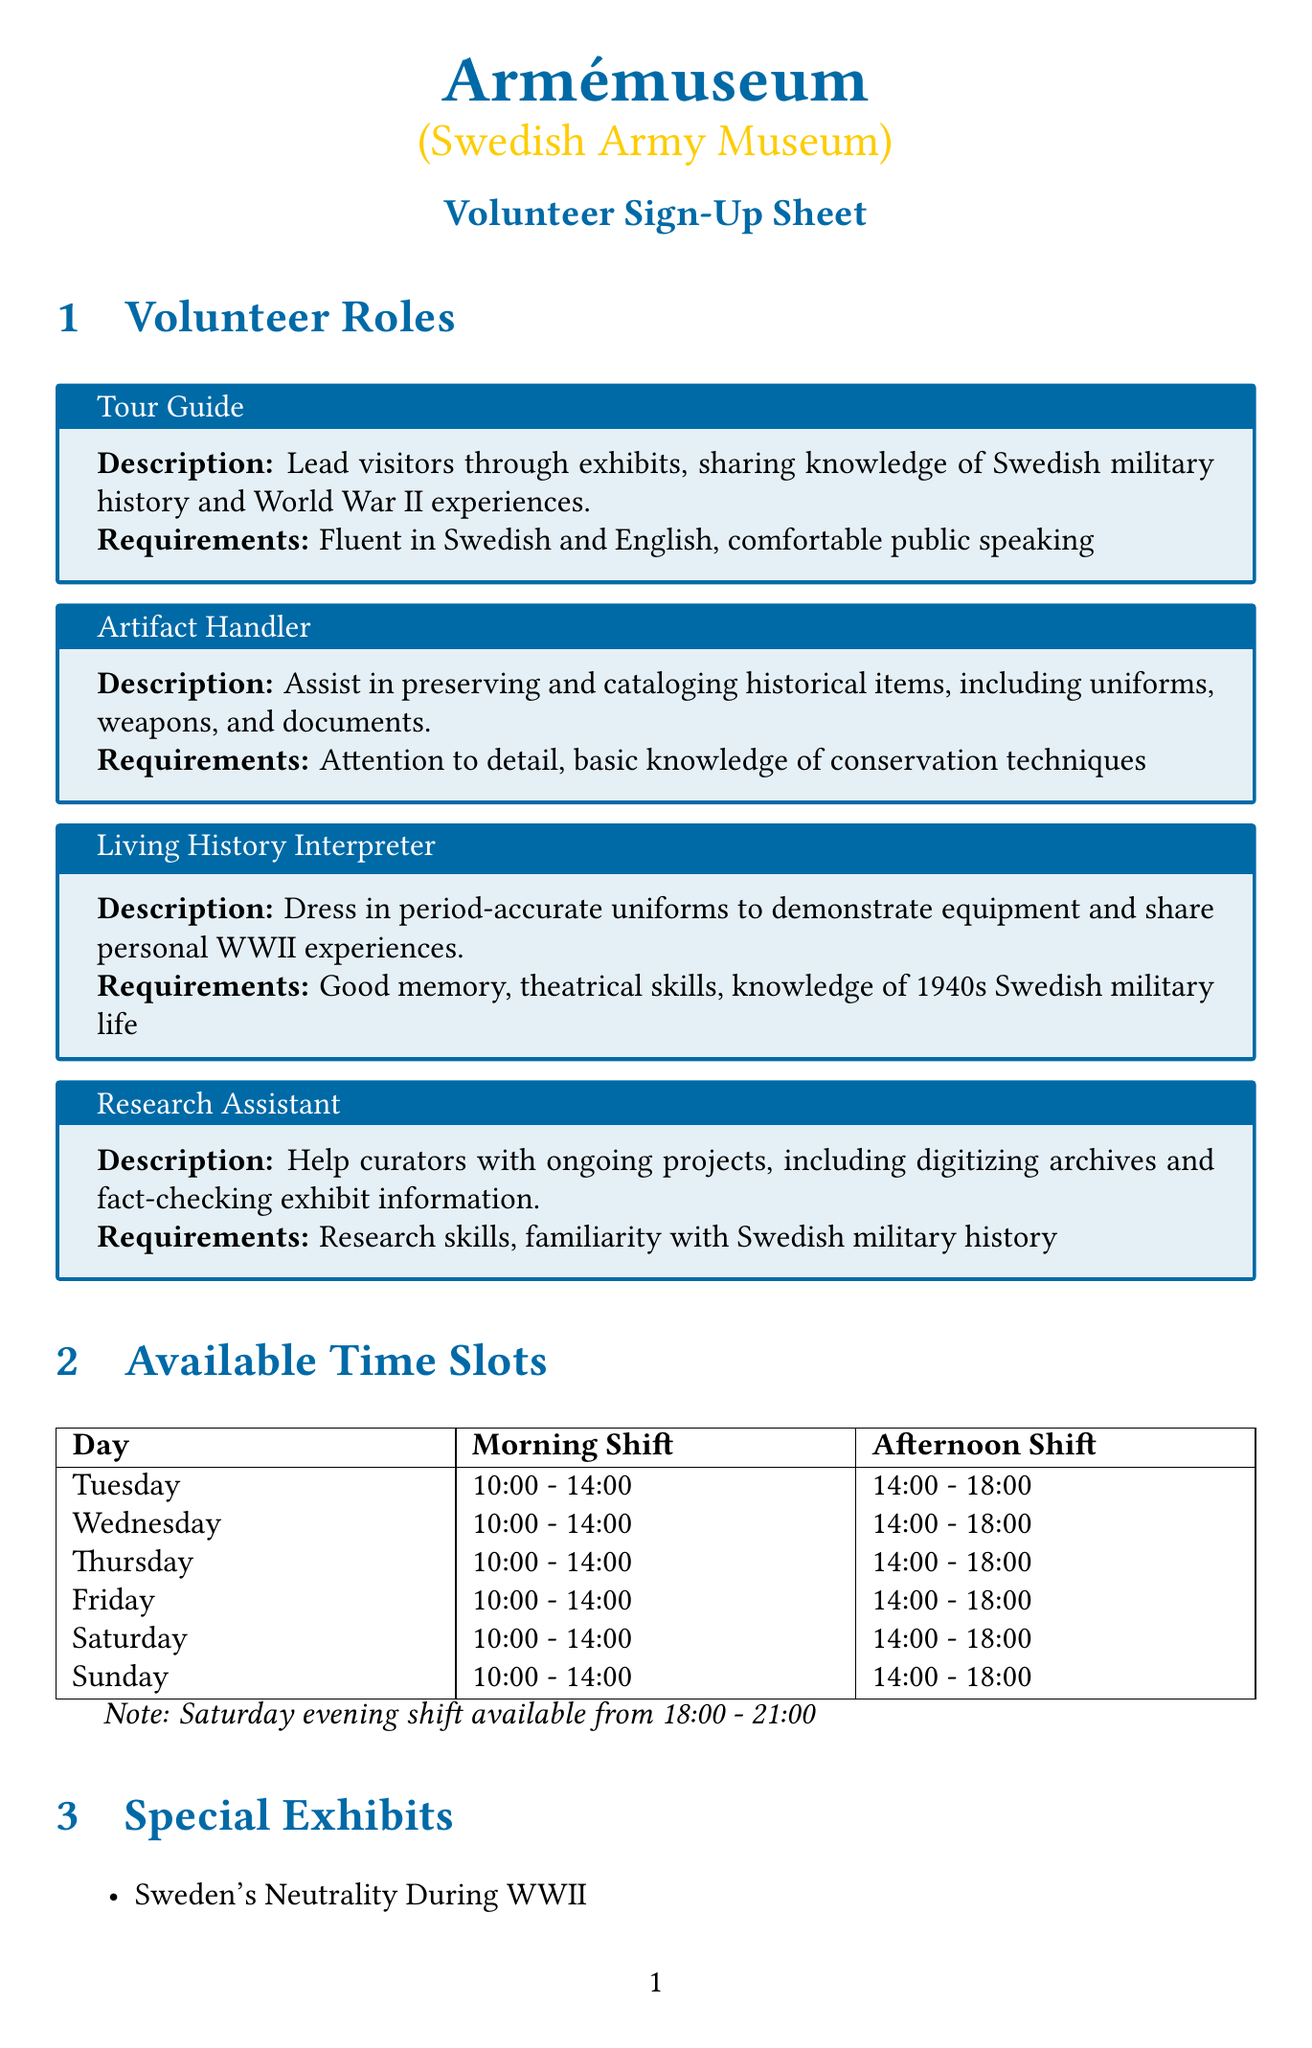What is the name of the museum? The name of the museum is stated in the document and is "Armémuseum (Swedish Army Museum)".
Answer: Armémuseum (Swedish Army Museum) Who is the coordinator for volunteers? The document provides the name of the volunteer coordinator, which is Major (Ret.) Sven Lindberg.
Answer: Major (Ret.) Sven Lindberg What are the requirements for the Tour Guide role? The requirements listed for the Tour Guide role are specific skills, including language proficiency and public speaking comfort.
Answer: Fluent in Swedish and English, comfortable public speaking How many special exhibits are mentioned? The document lists the number of special exhibits related to Swedish military history, which can be counted directly from the list provided.
Answer: 3 On which date is the orientation session in June scheduled? The document specifies a date for an orientation session in June, which can be found in the orientation sessions section.
Answer: June 1, 2023 What time slot is available on Saturdays that is not available on other days? The document specifies a special evening shift that is only available on Saturdays, mentioned in the time slots section.
Answer: 18:00 - 21:00 What benefit do volunteers receive at the museum shop? The document outlines the rewards and benefits for volunteers, including discounts at the museum shop.
Answer: 10% discount What is the earliest time slot on Wednesdays? The time slots provided in the document detail the shifts available on Wednesdays, with a specific focus on the morning shift.
Answer: 10:00 - 14:00 